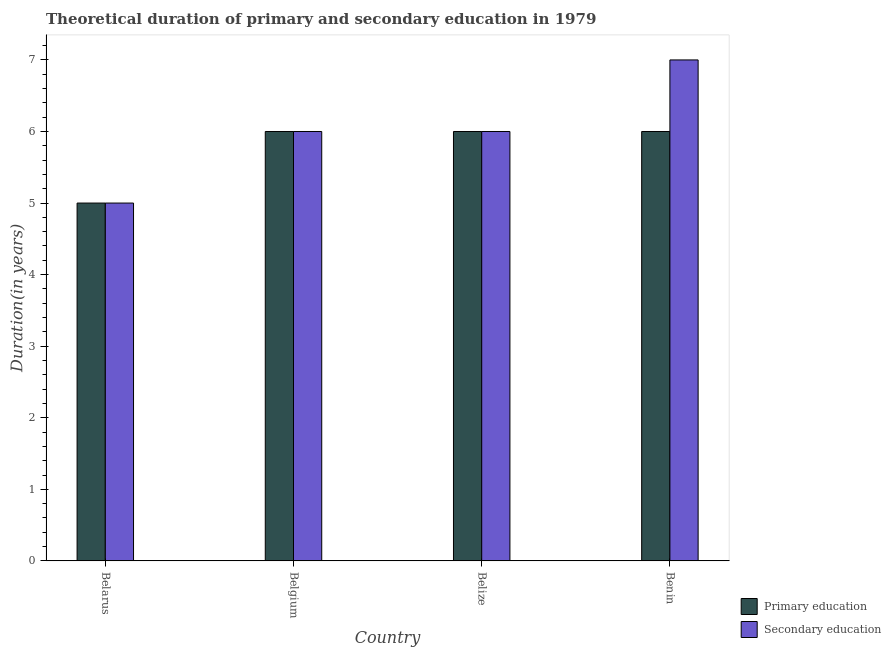Are the number of bars on each tick of the X-axis equal?
Give a very brief answer. Yes. How many bars are there on the 2nd tick from the left?
Keep it short and to the point. 2. What is the duration of primary education in Belarus?
Your answer should be compact. 5. Across all countries, what is the minimum duration of secondary education?
Your response must be concise. 5. In which country was the duration of primary education minimum?
Make the answer very short. Belarus. What is the total duration of secondary education in the graph?
Your answer should be compact. 24. What is the difference between the duration of secondary education in Belgium and that in Benin?
Provide a short and direct response. -1. What is the difference between the duration of primary education in Benin and the duration of secondary education in Belgium?
Offer a terse response. 0. What is the average duration of secondary education per country?
Your answer should be compact. 6. What is the difference between the duration of secondary education and duration of primary education in Belize?
Ensure brevity in your answer.  0. What is the ratio of the duration of secondary education in Belarus to that in Benin?
Make the answer very short. 0.71. Is the duration of primary education in Belgium less than that in Benin?
Offer a terse response. No. Is the difference between the duration of secondary education in Belarus and Belize greater than the difference between the duration of primary education in Belarus and Belize?
Keep it short and to the point. No. What is the difference between the highest and the lowest duration of primary education?
Ensure brevity in your answer.  1. In how many countries, is the duration of secondary education greater than the average duration of secondary education taken over all countries?
Your answer should be compact. 1. Is the sum of the duration of secondary education in Belize and Benin greater than the maximum duration of primary education across all countries?
Provide a short and direct response. Yes. What does the 2nd bar from the left in Belize represents?
Offer a very short reply. Secondary education. What does the 2nd bar from the right in Belgium represents?
Provide a succinct answer. Primary education. How many bars are there?
Offer a very short reply. 8. How many countries are there in the graph?
Keep it short and to the point. 4. Are the values on the major ticks of Y-axis written in scientific E-notation?
Your response must be concise. No. Does the graph contain any zero values?
Offer a very short reply. No. Where does the legend appear in the graph?
Ensure brevity in your answer.  Bottom right. What is the title of the graph?
Offer a very short reply. Theoretical duration of primary and secondary education in 1979. What is the label or title of the Y-axis?
Your response must be concise. Duration(in years). What is the Duration(in years) of Secondary education in Belarus?
Provide a succinct answer. 5. What is the Duration(in years) in Secondary education in Belgium?
Ensure brevity in your answer.  6. What is the Duration(in years) of Primary education in Belize?
Give a very brief answer. 6. What is the Duration(in years) of Secondary education in Belize?
Your answer should be compact. 6. What is the Duration(in years) of Primary education in Benin?
Offer a terse response. 6. Across all countries, what is the maximum Duration(in years) of Primary education?
Ensure brevity in your answer.  6. Across all countries, what is the minimum Duration(in years) in Secondary education?
Provide a short and direct response. 5. What is the total Duration(in years) in Secondary education in the graph?
Your answer should be compact. 24. What is the difference between the Duration(in years) in Secondary education in Belarus and that in Belize?
Your answer should be compact. -1. What is the difference between the Duration(in years) in Secondary education in Belarus and that in Benin?
Ensure brevity in your answer.  -2. What is the difference between the Duration(in years) in Primary education in Belgium and that in Belize?
Make the answer very short. 0. What is the difference between the Duration(in years) of Secondary education in Belgium and that in Belize?
Your answer should be very brief. 0. What is the difference between the Duration(in years) of Primary education in Belgium and that in Benin?
Offer a terse response. 0. What is the difference between the Duration(in years) of Primary education in Belize and that in Benin?
Give a very brief answer. 0. What is the difference between the Duration(in years) of Secondary education in Belize and that in Benin?
Your response must be concise. -1. What is the difference between the Duration(in years) in Primary education in Belarus and the Duration(in years) in Secondary education in Belgium?
Your response must be concise. -1. What is the difference between the Duration(in years) in Primary education in Belarus and the Duration(in years) in Secondary education in Belize?
Give a very brief answer. -1. What is the difference between the Duration(in years) of Primary education in Belgium and the Duration(in years) of Secondary education in Benin?
Keep it short and to the point. -1. What is the average Duration(in years) in Primary education per country?
Offer a very short reply. 5.75. What is the difference between the Duration(in years) in Primary education and Duration(in years) in Secondary education in Belgium?
Your response must be concise. 0. What is the difference between the Duration(in years) of Primary education and Duration(in years) of Secondary education in Belize?
Your answer should be very brief. 0. What is the difference between the Duration(in years) of Primary education and Duration(in years) of Secondary education in Benin?
Make the answer very short. -1. What is the ratio of the Duration(in years) in Primary education in Belarus to that in Belgium?
Offer a very short reply. 0.83. What is the ratio of the Duration(in years) of Secondary education in Belarus to that in Belgium?
Keep it short and to the point. 0.83. What is the ratio of the Duration(in years) in Primary education in Belarus to that in Belize?
Give a very brief answer. 0.83. What is the ratio of the Duration(in years) in Secondary education in Belarus to that in Belize?
Provide a succinct answer. 0.83. What is the ratio of the Duration(in years) in Secondary education in Belgium to that in Benin?
Your response must be concise. 0.86. What is the difference between the highest and the lowest Duration(in years) of Primary education?
Your response must be concise. 1. What is the difference between the highest and the lowest Duration(in years) in Secondary education?
Your answer should be compact. 2. 